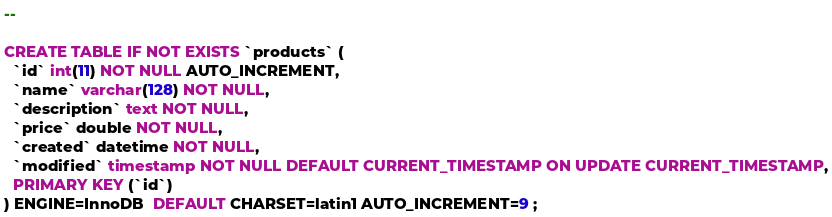<code> <loc_0><loc_0><loc_500><loc_500><_SQL_>--
 
CREATE TABLE IF NOT EXISTS `products` (
  `id` int(11) NOT NULL AUTO_INCREMENT,
  `name` varchar(128) NOT NULL,
  `description` text NOT NULL,
  `price` double NOT NULL,
  `created` datetime NOT NULL,
  `modified` timestamp NOT NULL DEFAULT CURRENT_TIMESTAMP ON UPDATE CURRENT_TIMESTAMP,
  PRIMARY KEY (`id`)
) ENGINE=InnoDB  DEFAULT CHARSET=latin1 AUTO_INCREMENT=9 ;</code> 